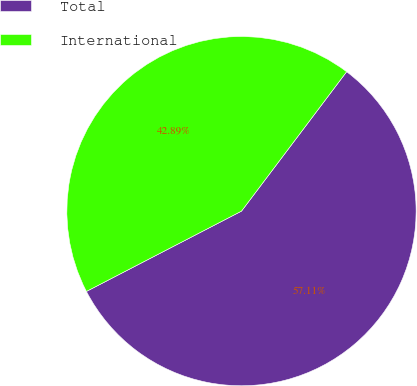<chart> <loc_0><loc_0><loc_500><loc_500><pie_chart><fcel>Total<fcel>International<nl><fcel>57.11%<fcel>42.89%<nl></chart> 